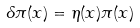Convert formula to latex. <formula><loc_0><loc_0><loc_500><loc_500>\delta \pi ( x ) = \eta ( x ) \pi ( x )</formula> 